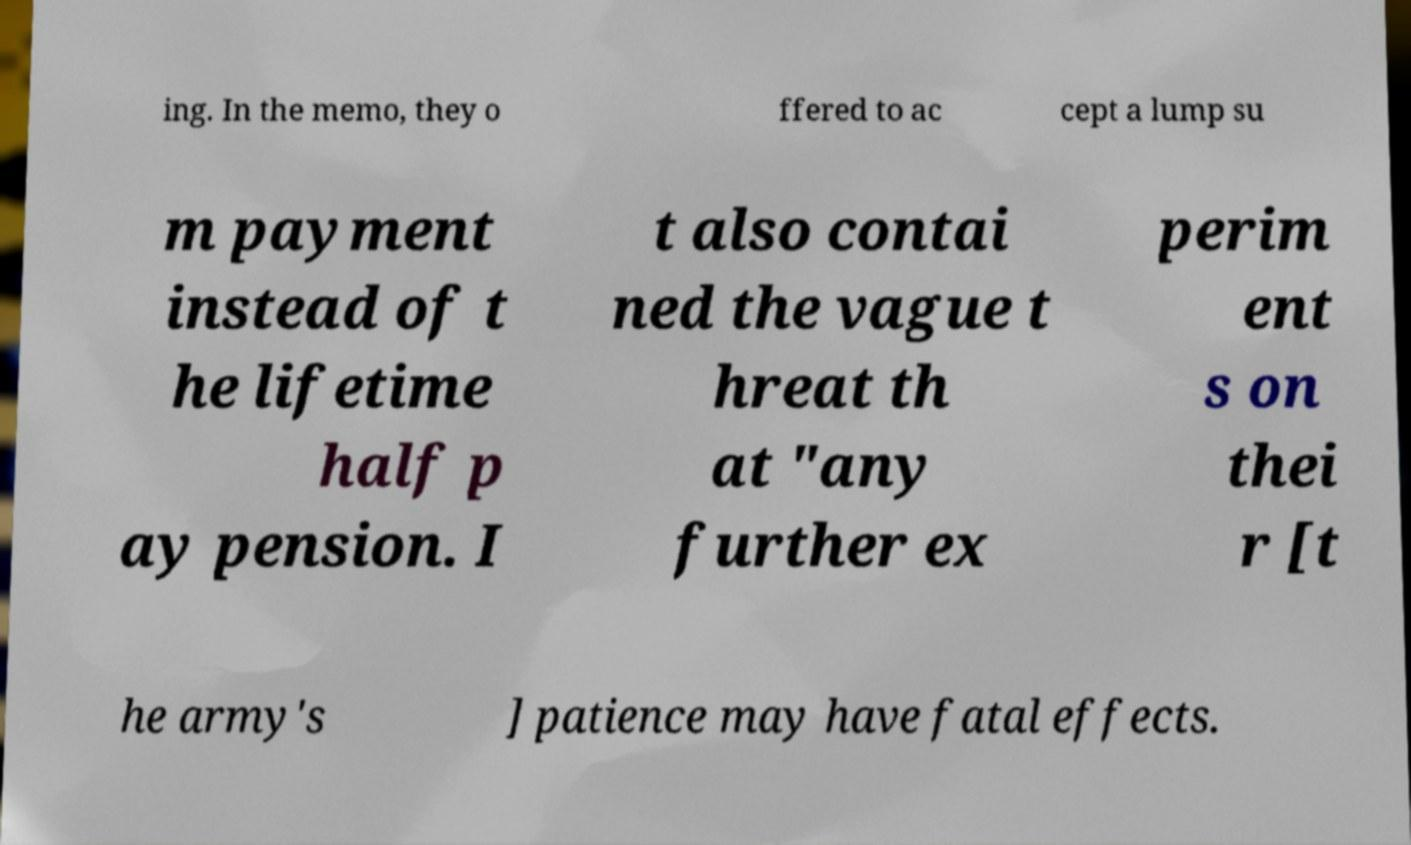Could you extract and type out the text from this image? ing. In the memo, they o ffered to ac cept a lump su m payment instead of t he lifetime half p ay pension. I t also contai ned the vague t hreat th at "any further ex perim ent s on thei r [t he army's ] patience may have fatal effects. 